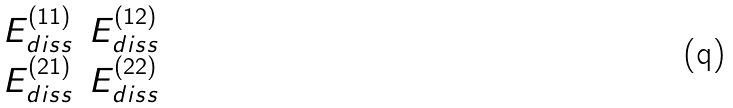Convert formula to latex. <formula><loc_0><loc_0><loc_500><loc_500>\begin{matrix} E _ { d i s s } ^ { ( 1 1 ) } & E _ { d i s s } ^ { ( 1 2 ) } \\ E _ { d i s s } ^ { ( 2 1 ) } & E _ { d i s s } ^ { ( 2 2 ) } \end{matrix}</formula> 